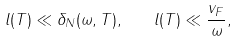<formula> <loc_0><loc_0><loc_500><loc_500>l ( T ) \ll \delta _ { N } ( \omega , T ) , \quad l ( T ) \ll \frac { v _ { F } } { \omega } ,</formula> 